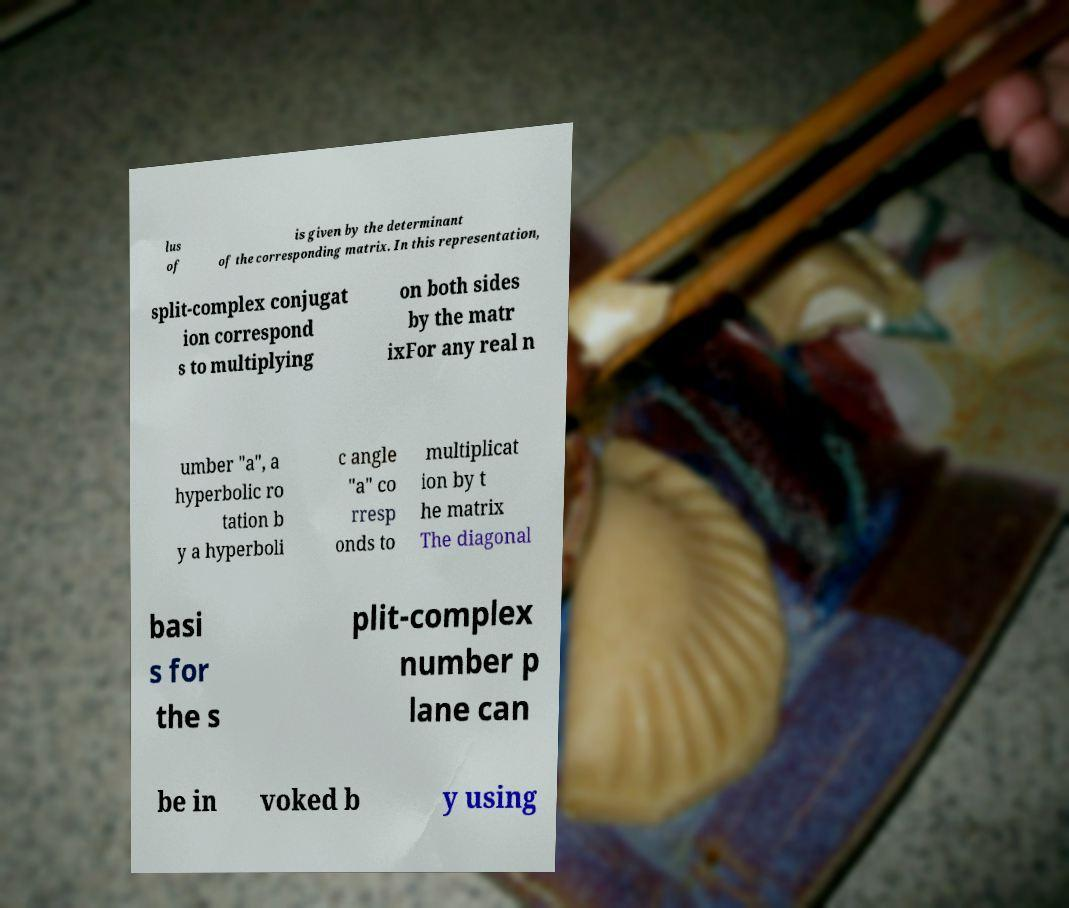What messages or text are displayed in this image? I need them in a readable, typed format. lus of is given by the determinant of the corresponding matrix. In this representation, split-complex conjugat ion correspond s to multiplying on both sides by the matr ixFor any real n umber "a", a hyperbolic ro tation b y a hyperboli c angle "a" co rresp onds to multiplicat ion by t he matrix The diagonal basi s for the s plit-complex number p lane can be in voked b y using 